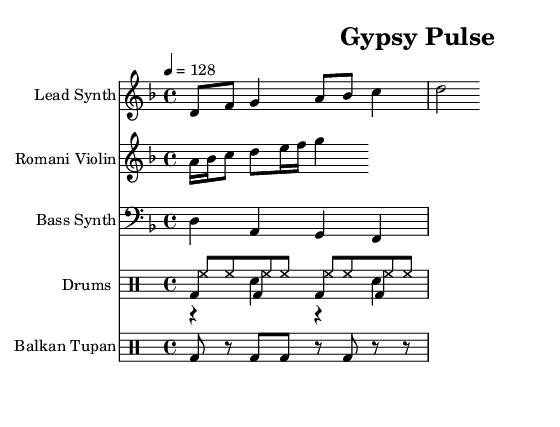What is the title of the piece? The title is indicated at the beginning of the sheet music under the header section. It reads "Gypsy Pulse."
Answer: Gypsy Pulse What is the time signature of this music? The time signature is found in the global section of the music notation, noted as 4/4, meaning there are four beats per measure.
Answer: 4/4 What is the tempo marking of the piece? The tempo is specified in the global section and indicates the speed of the music. It states "4 = 128," which means the quarter note gets a beat of 128 beats per minute.
Answer: 128 What key is this music written in? The key signature displayed in the global section is the first element, which shows D minor. This is characterized by one flat (B flat) and is the tonal center for the piece.
Answer: D minor Which instrument plays the lead melody? The lead melody is indicated by the first staff labeled "Lead Synth." It contains the notes that represent the main melodic lines of the piece.
Answer: Lead Synth How many different types of drums are used in this composition? By examining the drum sections, we see there are three distinct parts: the kick drum, snare drum, and hi-hat. Each is specified in its own respective drum voice.
Answer: Three What cultural influence is integrated into this House music style? The sheet music indicates a fusion element with "Romani folk music," which suggests the cultural aspect integrated alongside the electronic beats of House music.
Answer: Romani folk music 